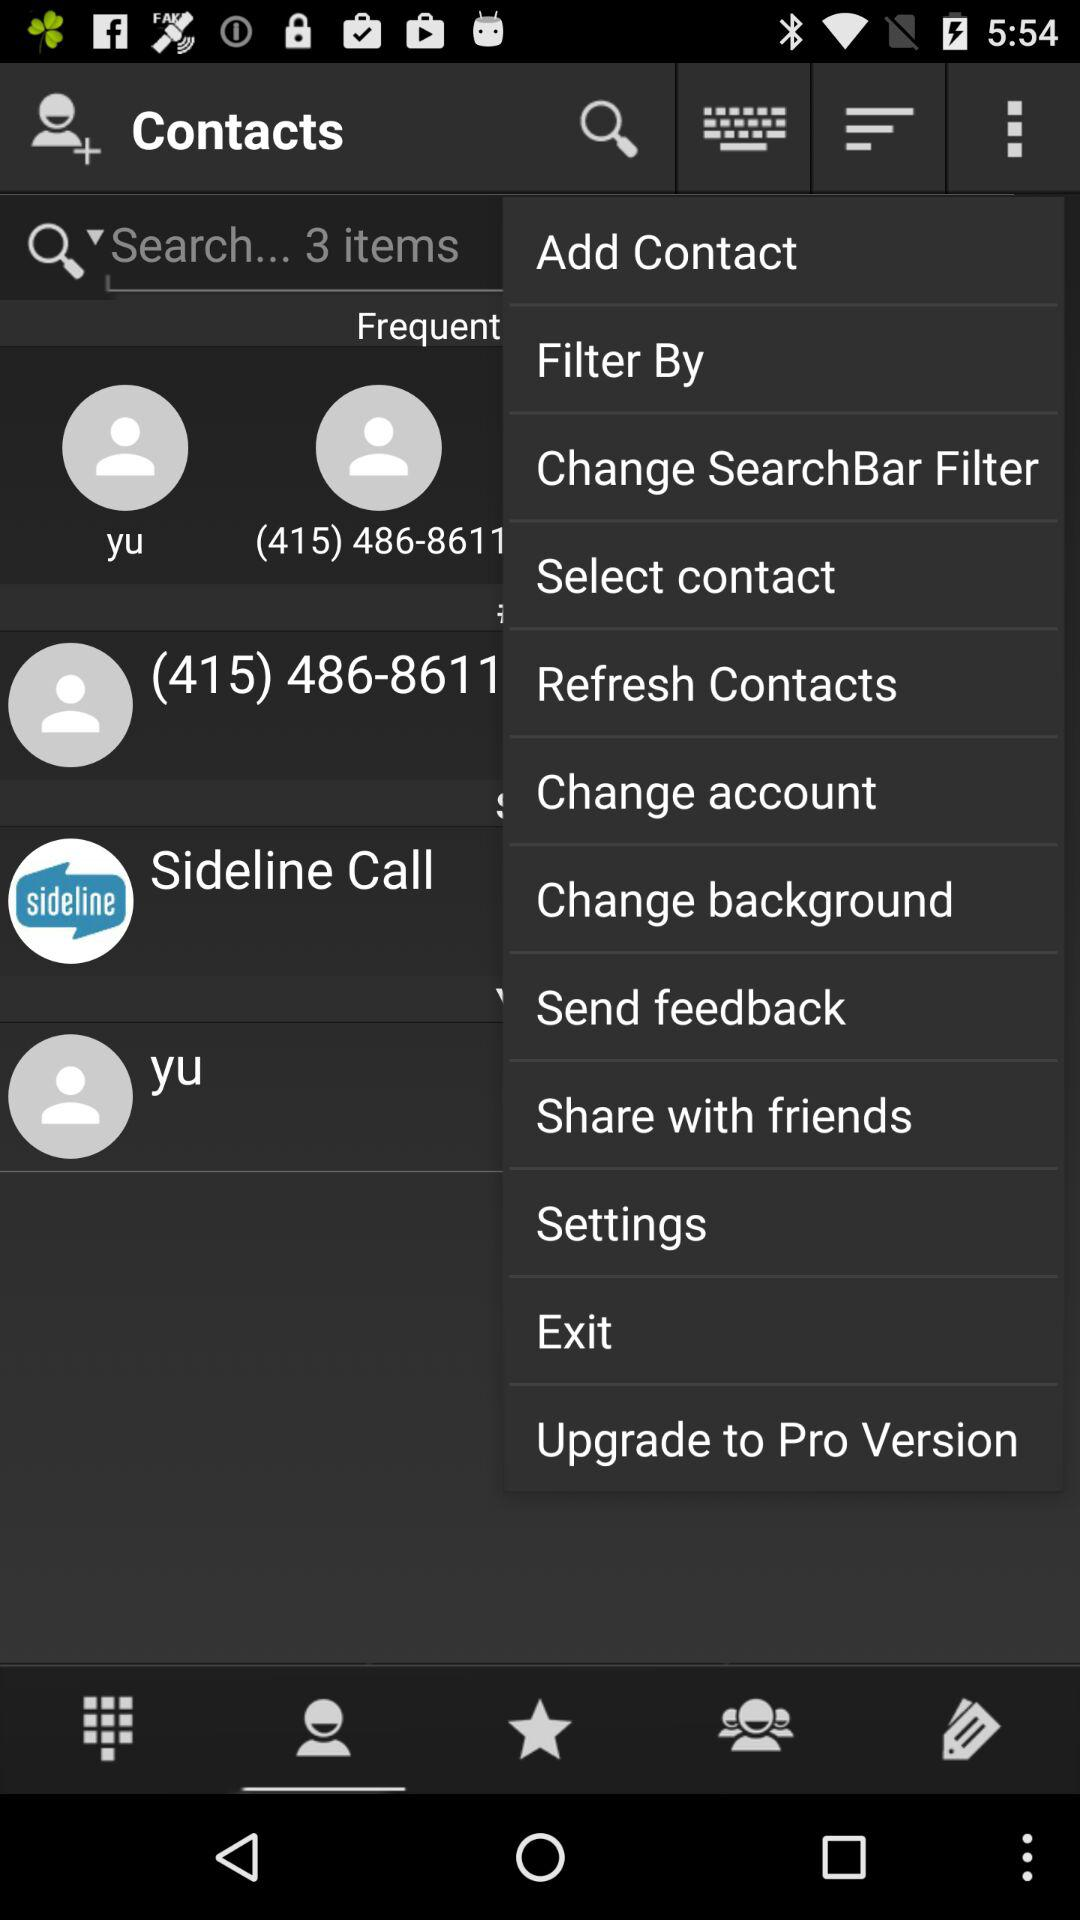What is the app name? The app name is "Contacts". 